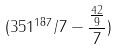Convert formula to latex. <formula><loc_0><loc_0><loc_500><loc_500>( 3 5 1 ^ { 1 8 7 } / 7 - \frac { \frac { 4 2 } { 9 } } { 7 } )</formula> 